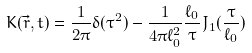<formula> <loc_0><loc_0><loc_500><loc_500>K ( \vec { r } , t ) = \frac { 1 } { 2 \pi } \delta ( \tau ^ { 2 } ) - \frac { 1 } { 4 \pi \ell _ { 0 } ^ { 2 } } \frac { \ell _ { 0 } } { \tau } J _ { 1 } ( \frac { \tau } { \ell _ { 0 } } )</formula> 